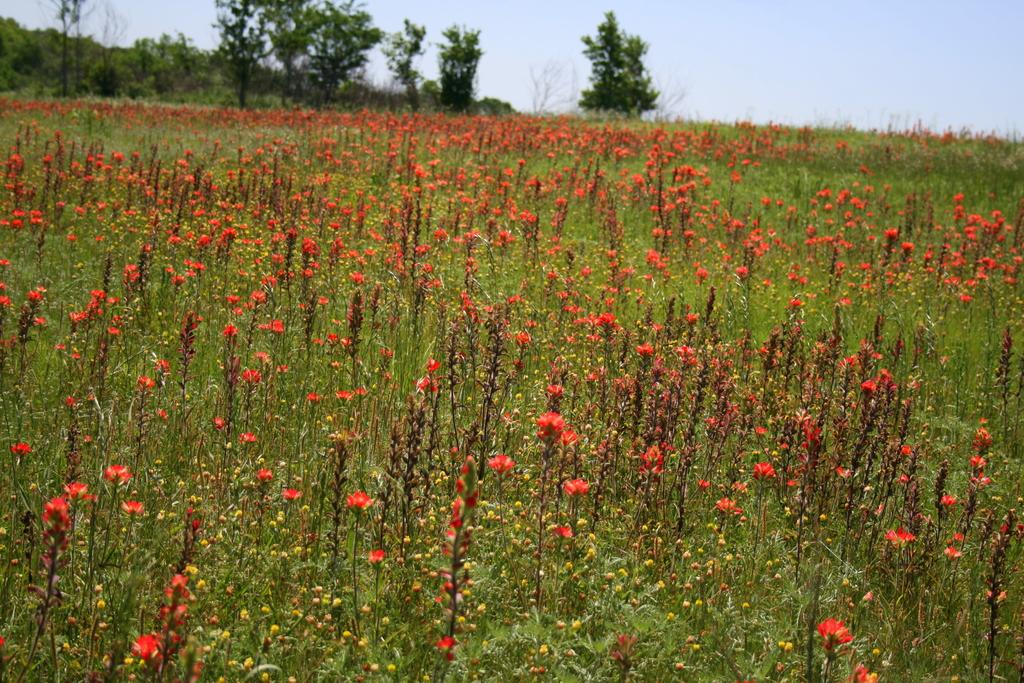What type of living organisms can be seen in the image? Plants and flowers are visible in the image. What type of vegetation can be seen in the background of the image? There are trees in the background of the image. What is visible at the top of the image? The sky is visible at the top of the image. What type of hospital can be seen in the image? There is no hospital present in the image; it features plants, flowers, trees, and the sky. 